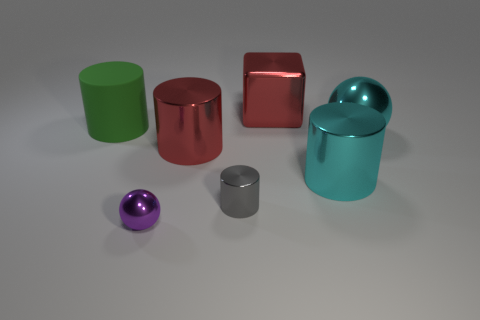Add 3 purple objects. How many objects exist? 10 Subtract all spheres. How many objects are left? 5 Subtract 1 red cylinders. How many objects are left? 6 Subtract all small purple metallic spheres. Subtract all small purple shiny objects. How many objects are left? 5 Add 1 red shiny cylinders. How many red shiny cylinders are left? 2 Add 2 small gray metallic cylinders. How many small gray metallic cylinders exist? 3 